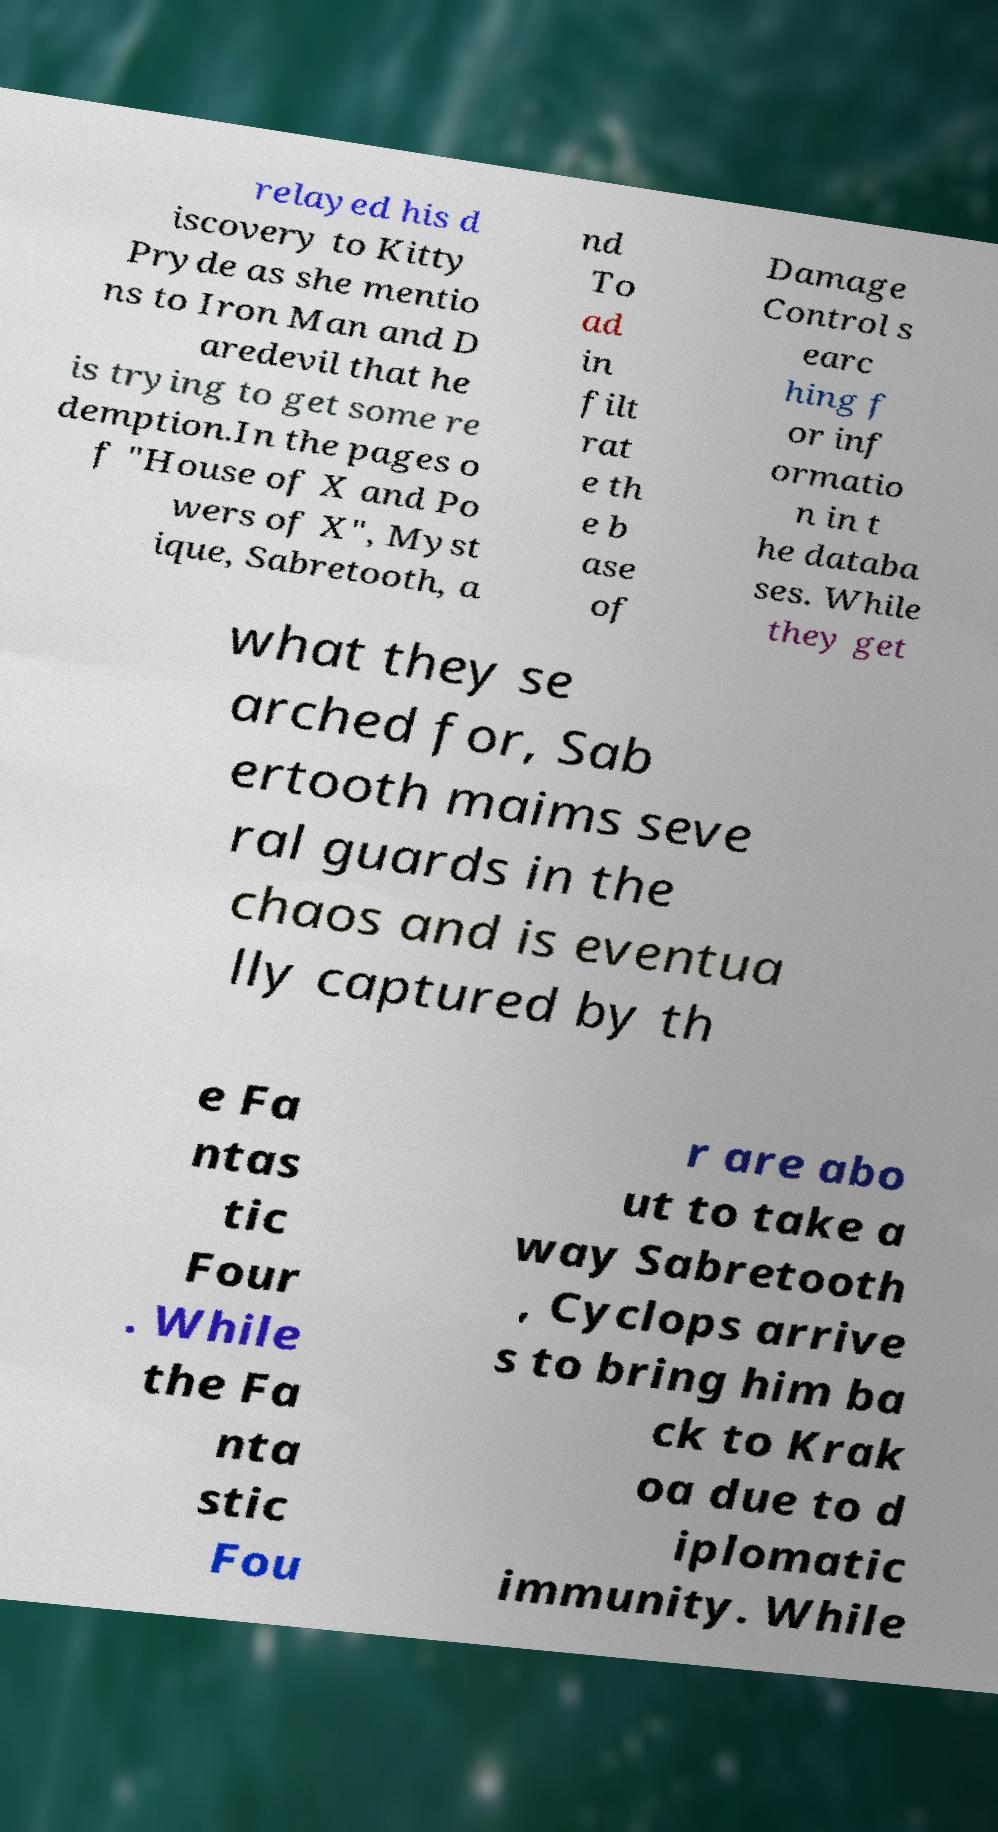Could you extract and type out the text from this image? relayed his d iscovery to Kitty Pryde as she mentio ns to Iron Man and D aredevil that he is trying to get some re demption.In the pages o f "House of X and Po wers of X", Myst ique, Sabretooth, a nd To ad in filt rat e th e b ase of Damage Control s earc hing f or inf ormatio n in t he databa ses. While they get what they se arched for, Sab ertooth maims seve ral guards in the chaos and is eventua lly captured by th e Fa ntas tic Four . While the Fa nta stic Fou r are abo ut to take a way Sabretooth , Cyclops arrive s to bring him ba ck to Krak oa due to d iplomatic immunity. While 